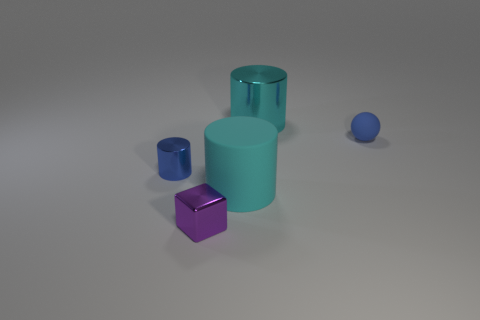Subtract all tiny metallic cylinders. How many cylinders are left? 2 Add 1 tiny blue rubber balls. How many objects exist? 6 Subtract 1 cylinders. How many cylinders are left? 2 Subtract all cubes. How many objects are left? 4 Subtract 0 brown cylinders. How many objects are left? 5 Subtract all small cylinders. Subtract all purple things. How many objects are left? 3 Add 3 cyan things. How many cyan things are left? 5 Add 3 blue shiny cylinders. How many blue shiny cylinders exist? 4 